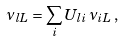<formula> <loc_0><loc_0><loc_500><loc_500>\nu _ { { l } L } = \sum _ { i } U _ { { l } i } \, \nu _ { i L } \, ,</formula> 